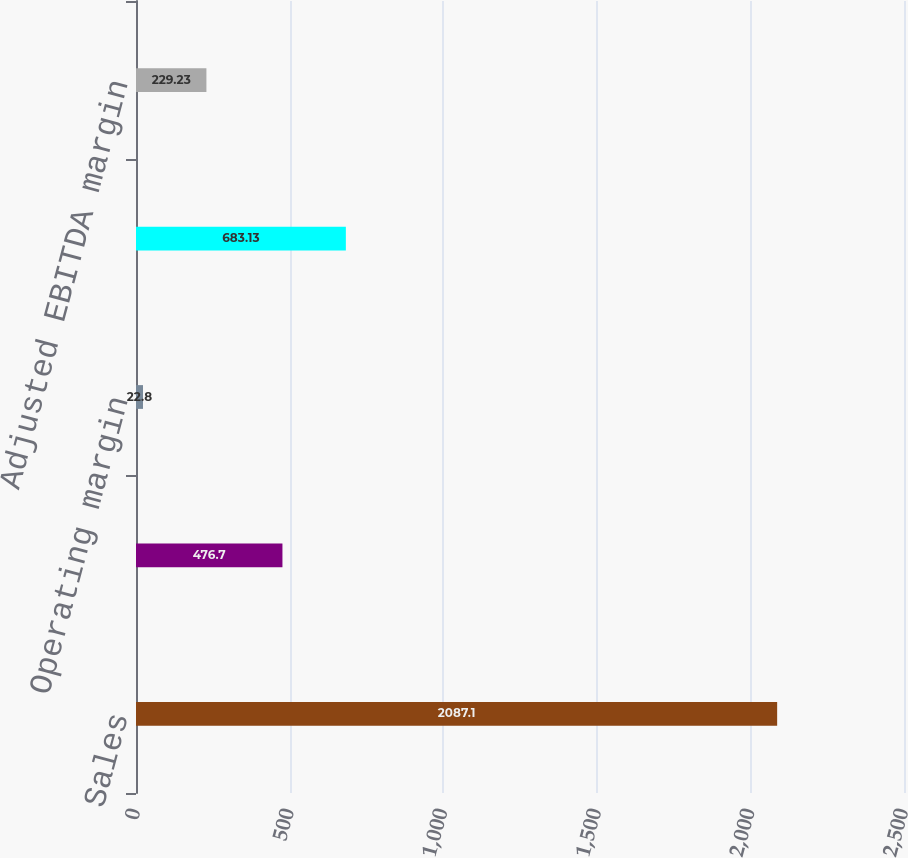Convert chart. <chart><loc_0><loc_0><loc_500><loc_500><bar_chart><fcel>Sales<fcel>Operating income<fcel>Operating margin<fcel>Adjusted EBITDA<fcel>Adjusted EBITDA margin<nl><fcel>2087.1<fcel>476.7<fcel>22.8<fcel>683.13<fcel>229.23<nl></chart> 